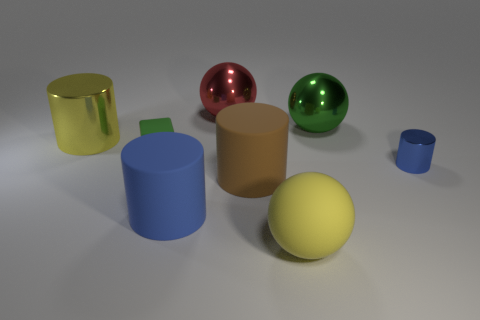Is there any pattern or symmetry in the arrangement of the objects? The objects appear to be randomly placed without a specific pattern or symmetry. Their sizes and positions don't follow a discernible sequence or alignment.  Do the different finishes of the objects represent any particular significance? The various finishes on the objects—metallic, glossy, and matte—could be used to study how light interacts with different surfaces or to showcase the visual contrasts between materials. There's no inherent significance to their arrangement, but they could be employed for educational or illustrative purposes. 